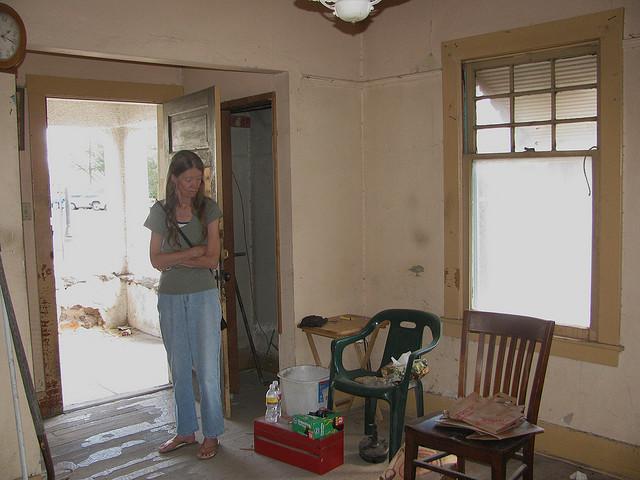How many places are there to sit?
Give a very brief answer. 2. How many chairs are in the photo?
Give a very brief answer. 2. 